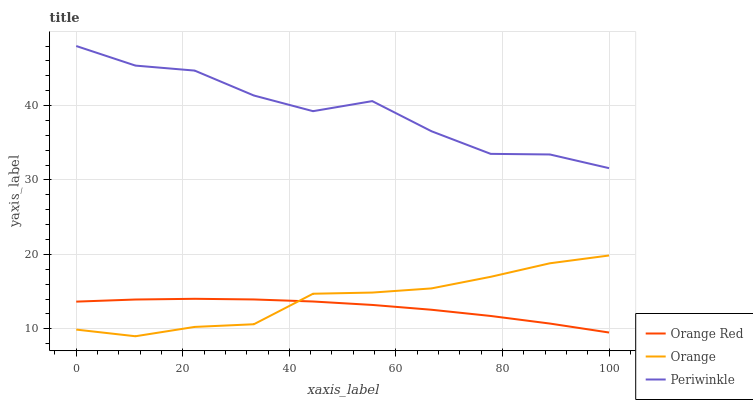Does Periwinkle have the minimum area under the curve?
Answer yes or no. No. Does Orange Red have the maximum area under the curve?
Answer yes or no. No. Is Periwinkle the smoothest?
Answer yes or no. No. Is Orange Red the roughest?
Answer yes or no. No. Does Orange Red have the lowest value?
Answer yes or no. No. Does Orange Red have the highest value?
Answer yes or no. No. Is Orange less than Periwinkle?
Answer yes or no. Yes. Is Periwinkle greater than Orange?
Answer yes or no. Yes. Does Orange intersect Periwinkle?
Answer yes or no. No. 